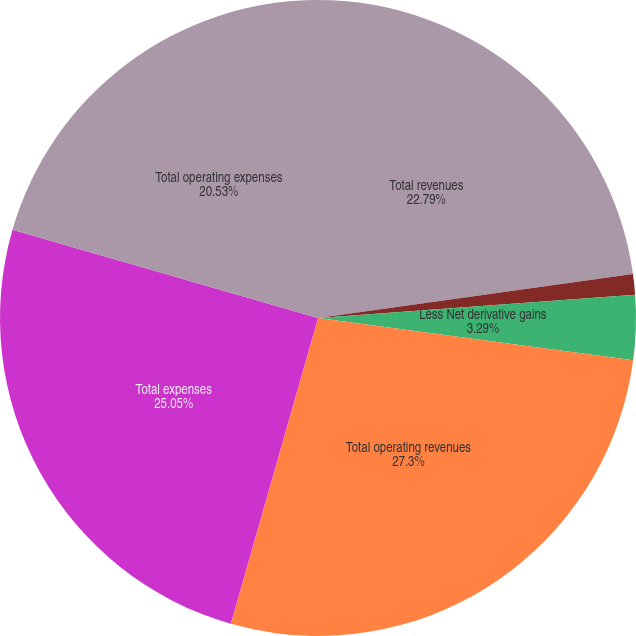Convert chart. <chart><loc_0><loc_0><loc_500><loc_500><pie_chart><fcel>Total revenues<fcel>Less Net investment gains<fcel>Less Net derivative gains<fcel>Total operating revenues<fcel>Total expenses<fcel>Total operating expenses<nl><fcel>22.79%<fcel>1.04%<fcel>3.29%<fcel>27.3%<fcel>25.05%<fcel>20.53%<nl></chart> 